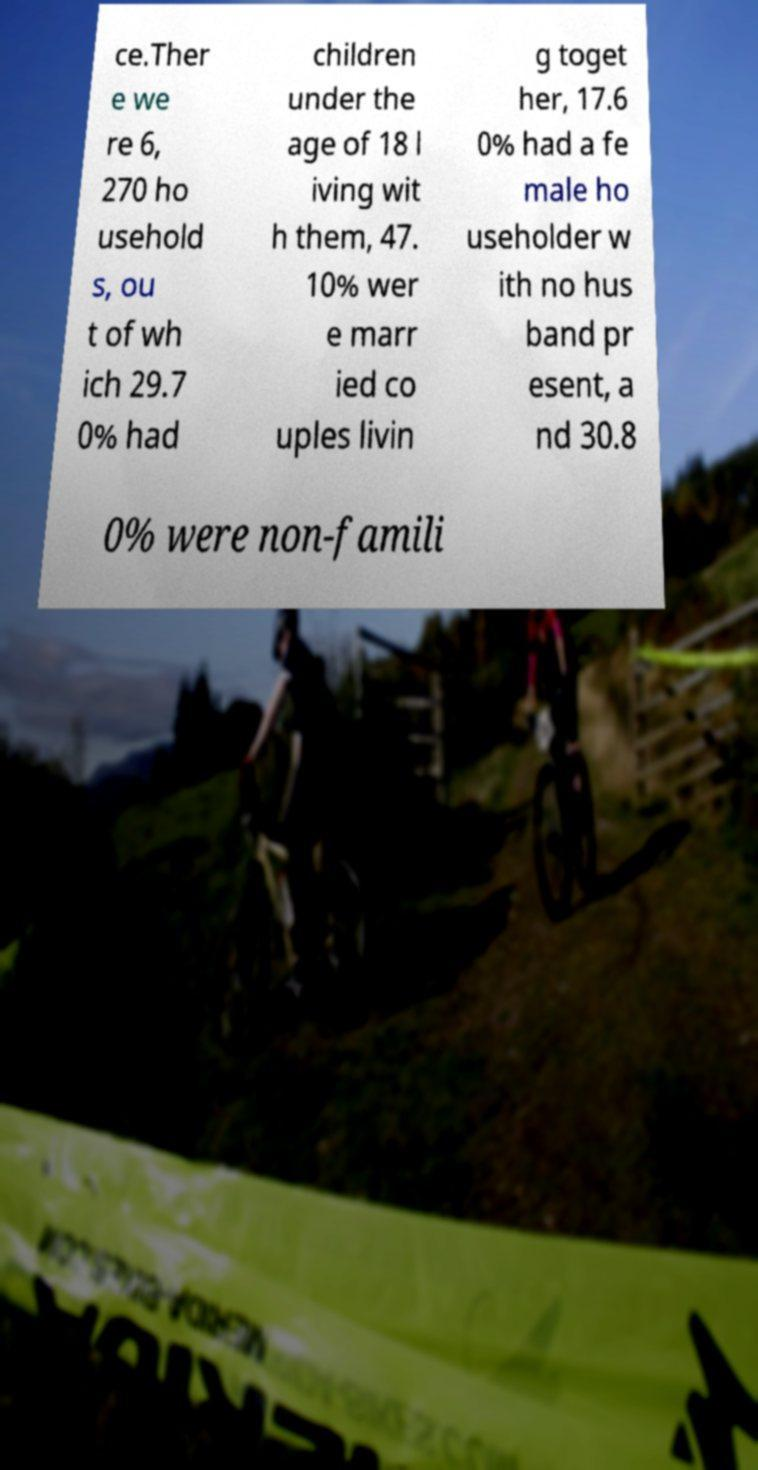Please identify and transcribe the text found in this image. ce.Ther e we re 6, 270 ho usehold s, ou t of wh ich 29.7 0% had children under the age of 18 l iving wit h them, 47. 10% wer e marr ied co uples livin g toget her, 17.6 0% had a fe male ho useholder w ith no hus band pr esent, a nd 30.8 0% were non-famili 